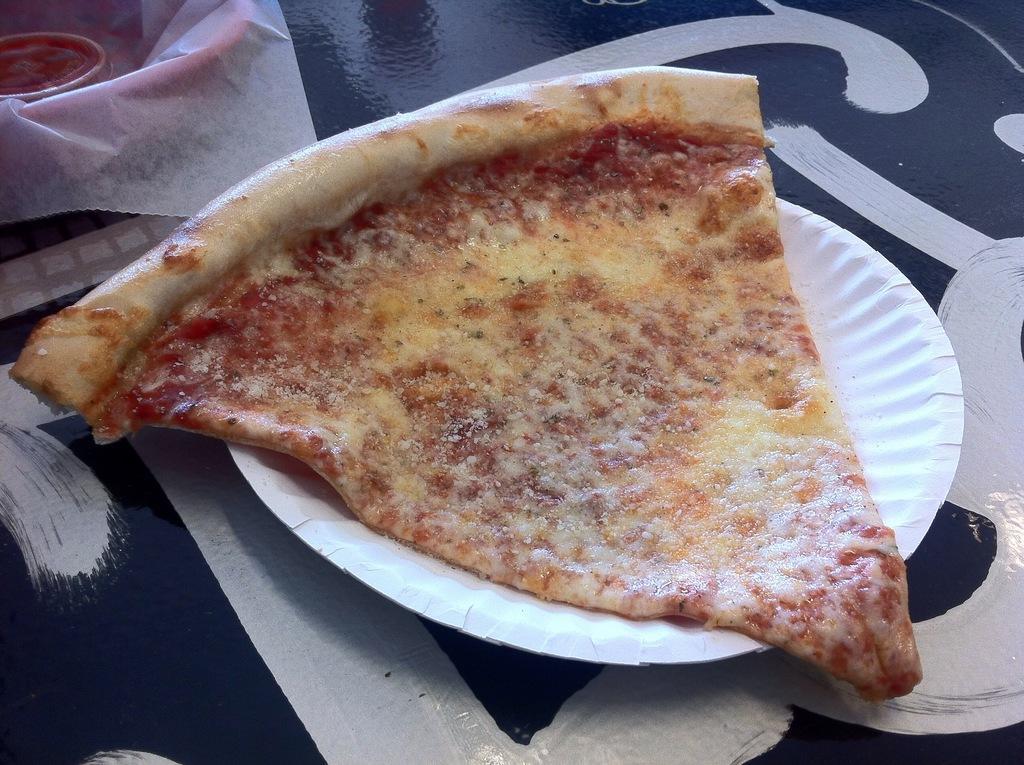Please provide a concise description of this image. In this image I can see a white colour plate and in it I can see a slice of a pizza. On the top left side of this image I can see a white colour paper and other things. 